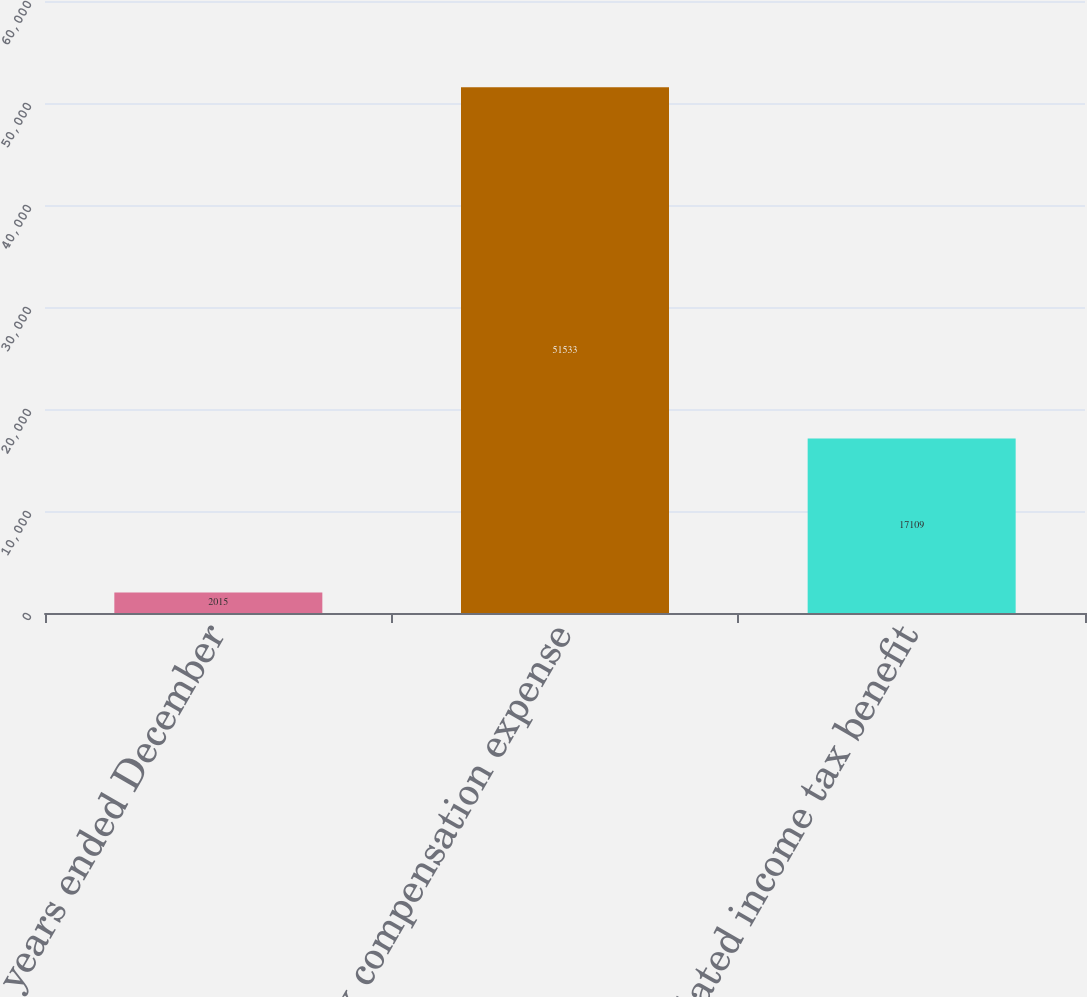<chart> <loc_0><loc_0><loc_500><loc_500><bar_chart><fcel>For the years ended December<fcel>Pre-tax compensation expense<fcel>Related income tax benefit<nl><fcel>2015<fcel>51533<fcel>17109<nl></chart> 